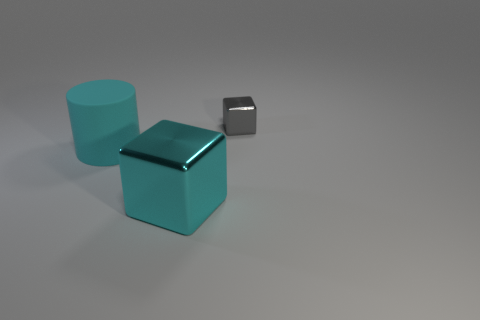There is a matte object that is the same color as the large shiny object; what is its shape?
Offer a very short reply. Cylinder. There is a large thing that is behind the block left of the small gray shiny block; how many objects are in front of it?
Give a very brief answer. 1. There is a big cylinder; is it the same color as the block that is in front of the gray metallic thing?
Offer a very short reply. Yes. What number of objects are either big objects that are right of the large rubber object or big objects on the right side of the large matte object?
Provide a succinct answer. 1. Is the number of large objects to the right of the cyan rubber cylinder greater than the number of small blocks to the left of the tiny gray object?
Provide a short and direct response. Yes. What is the material of the cube behind the metal thing that is left of the metallic cube that is behind the big cyan rubber thing?
Provide a succinct answer. Metal. There is a big cyan object on the right side of the rubber cylinder; does it have the same shape as the shiny thing right of the large cyan metal object?
Keep it short and to the point. Yes. Is there a purple block that has the same size as the gray cube?
Your response must be concise. No. What number of cyan objects are either tiny matte balls or cylinders?
Provide a short and direct response. 1. What number of big shiny things are the same color as the matte cylinder?
Offer a very short reply. 1. 